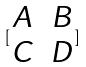Convert formula to latex. <formula><loc_0><loc_0><loc_500><loc_500>[ \begin{matrix} A & B \\ C & D \end{matrix} ]</formula> 